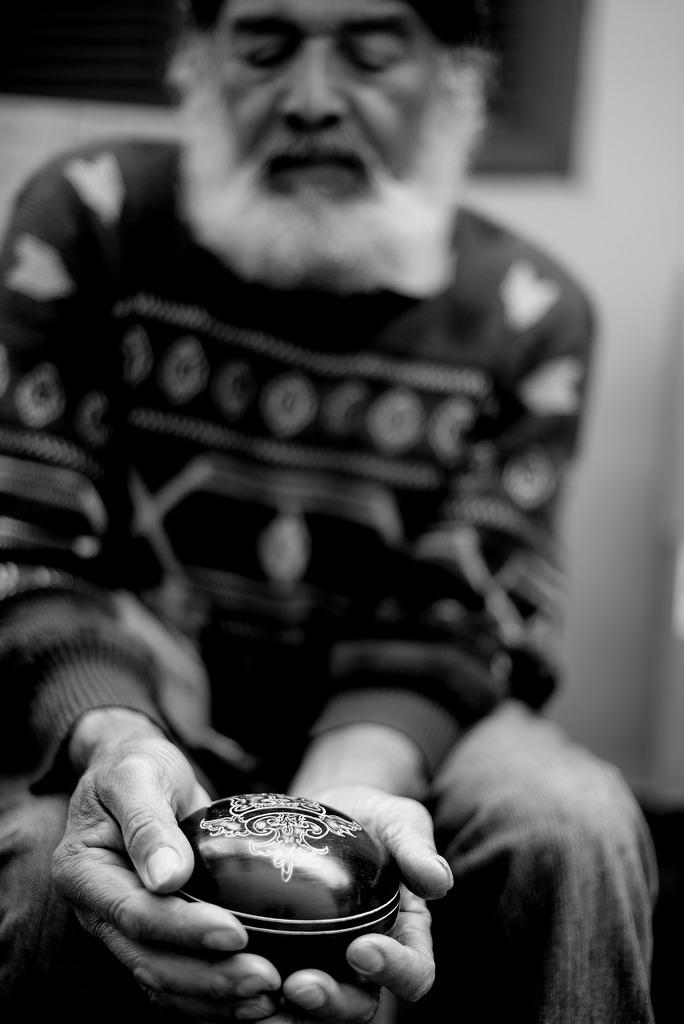Who is present in the image? There is a man in the image. What is the man doing in the image? The man is sitting on a chair in the image. What is the man holding in his hands? The man is holding an object in his hands in the image. What can be seen in the background of the image? There is a wall in the background of the image. What grade did the man receive for his performance in the image? There is no indication of a performance or grade in the image; it simply shows a man sitting on a chair and holding an object. 